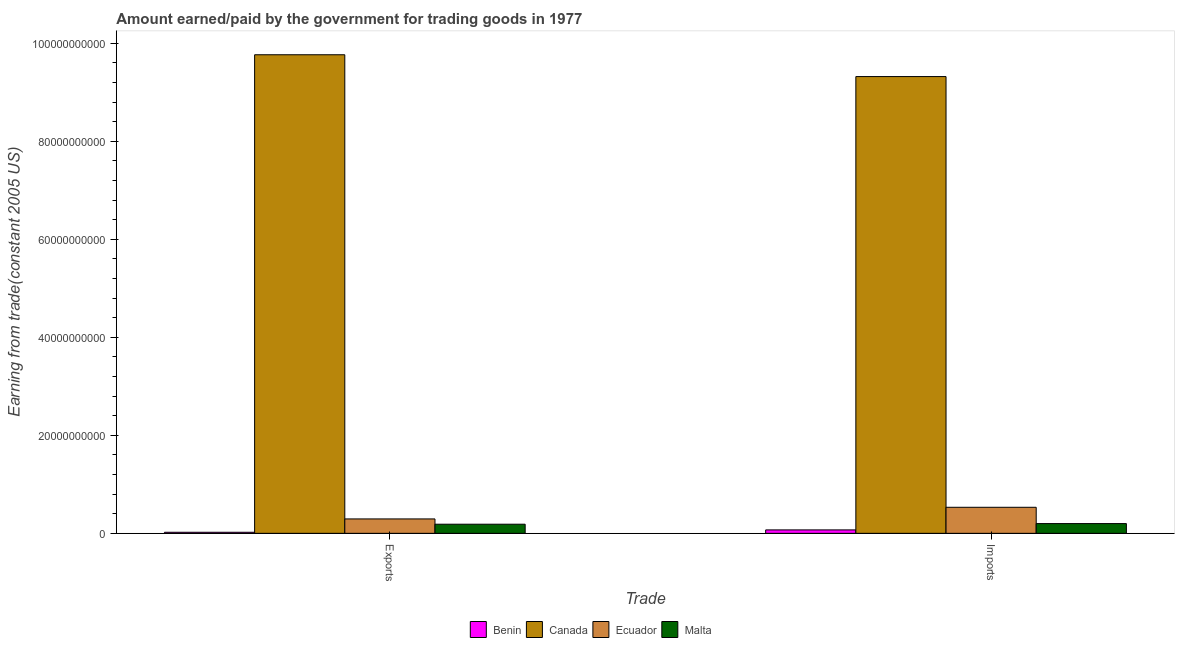How many groups of bars are there?
Your answer should be compact. 2. Are the number of bars per tick equal to the number of legend labels?
Offer a terse response. Yes. What is the label of the 1st group of bars from the left?
Your answer should be compact. Exports. What is the amount paid for imports in Malta?
Offer a terse response. 1.99e+09. Across all countries, what is the maximum amount paid for imports?
Provide a succinct answer. 9.32e+1. Across all countries, what is the minimum amount paid for imports?
Keep it short and to the point. 7.00e+08. In which country was the amount earned from exports minimum?
Provide a short and direct response. Benin. What is the total amount paid for imports in the graph?
Offer a very short reply. 1.01e+11. What is the difference between the amount paid for imports in Malta and that in Ecuador?
Make the answer very short. -3.33e+09. What is the difference between the amount earned from exports in Malta and the amount paid for imports in Benin?
Offer a terse response. 1.16e+09. What is the average amount earned from exports per country?
Your response must be concise. 2.57e+1. What is the difference between the amount paid for imports and amount earned from exports in Ecuador?
Make the answer very short. 2.38e+09. What is the ratio of the amount earned from exports in Ecuador to that in Canada?
Provide a short and direct response. 0.03. What does the 1st bar from the left in Exports represents?
Your answer should be compact. Benin. What does the 4th bar from the right in Exports represents?
Your answer should be compact. Benin. How many countries are there in the graph?
Your response must be concise. 4. What is the difference between two consecutive major ticks on the Y-axis?
Your answer should be very brief. 2.00e+1. Are the values on the major ticks of Y-axis written in scientific E-notation?
Keep it short and to the point. No. How many legend labels are there?
Your response must be concise. 4. What is the title of the graph?
Provide a succinct answer. Amount earned/paid by the government for trading goods in 1977. What is the label or title of the X-axis?
Give a very brief answer. Trade. What is the label or title of the Y-axis?
Provide a short and direct response. Earning from trade(constant 2005 US). What is the Earning from trade(constant 2005 US) in Benin in Exports?
Ensure brevity in your answer.  2.16e+08. What is the Earning from trade(constant 2005 US) in Canada in Exports?
Give a very brief answer. 9.77e+1. What is the Earning from trade(constant 2005 US) of Ecuador in Exports?
Keep it short and to the point. 2.94e+09. What is the Earning from trade(constant 2005 US) of Malta in Exports?
Ensure brevity in your answer.  1.86e+09. What is the Earning from trade(constant 2005 US) of Benin in Imports?
Offer a terse response. 7.00e+08. What is the Earning from trade(constant 2005 US) of Canada in Imports?
Your answer should be very brief. 9.32e+1. What is the Earning from trade(constant 2005 US) of Ecuador in Imports?
Make the answer very short. 5.32e+09. What is the Earning from trade(constant 2005 US) of Malta in Imports?
Your answer should be compact. 1.99e+09. Across all Trade, what is the maximum Earning from trade(constant 2005 US) in Benin?
Keep it short and to the point. 7.00e+08. Across all Trade, what is the maximum Earning from trade(constant 2005 US) in Canada?
Your answer should be very brief. 9.77e+1. Across all Trade, what is the maximum Earning from trade(constant 2005 US) in Ecuador?
Offer a terse response. 5.32e+09. Across all Trade, what is the maximum Earning from trade(constant 2005 US) in Malta?
Your answer should be compact. 1.99e+09. Across all Trade, what is the minimum Earning from trade(constant 2005 US) of Benin?
Make the answer very short. 2.16e+08. Across all Trade, what is the minimum Earning from trade(constant 2005 US) in Canada?
Give a very brief answer. 9.32e+1. Across all Trade, what is the minimum Earning from trade(constant 2005 US) in Ecuador?
Your response must be concise. 2.94e+09. Across all Trade, what is the minimum Earning from trade(constant 2005 US) in Malta?
Ensure brevity in your answer.  1.86e+09. What is the total Earning from trade(constant 2005 US) of Benin in the graph?
Offer a terse response. 9.15e+08. What is the total Earning from trade(constant 2005 US) in Canada in the graph?
Your answer should be compact. 1.91e+11. What is the total Earning from trade(constant 2005 US) of Ecuador in the graph?
Ensure brevity in your answer.  8.26e+09. What is the total Earning from trade(constant 2005 US) of Malta in the graph?
Your answer should be compact. 3.85e+09. What is the difference between the Earning from trade(constant 2005 US) of Benin in Exports and that in Imports?
Give a very brief answer. -4.84e+08. What is the difference between the Earning from trade(constant 2005 US) of Canada in Exports and that in Imports?
Give a very brief answer. 4.45e+09. What is the difference between the Earning from trade(constant 2005 US) in Ecuador in Exports and that in Imports?
Offer a terse response. -2.38e+09. What is the difference between the Earning from trade(constant 2005 US) of Malta in Exports and that in Imports?
Offer a very short reply. -1.30e+08. What is the difference between the Earning from trade(constant 2005 US) in Benin in Exports and the Earning from trade(constant 2005 US) in Canada in Imports?
Provide a succinct answer. -9.30e+1. What is the difference between the Earning from trade(constant 2005 US) of Benin in Exports and the Earning from trade(constant 2005 US) of Ecuador in Imports?
Provide a succinct answer. -5.10e+09. What is the difference between the Earning from trade(constant 2005 US) of Benin in Exports and the Earning from trade(constant 2005 US) of Malta in Imports?
Provide a short and direct response. -1.77e+09. What is the difference between the Earning from trade(constant 2005 US) in Canada in Exports and the Earning from trade(constant 2005 US) in Ecuador in Imports?
Give a very brief answer. 9.23e+1. What is the difference between the Earning from trade(constant 2005 US) in Canada in Exports and the Earning from trade(constant 2005 US) in Malta in Imports?
Your response must be concise. 9.57e+1. What is the difference between the Earning from trade(constant 2005 US) of Ecuador in Exports and the Earning from trade(constant 2005 US) of Malta in Imports?
Offer a terse response. 9.49e+08. What is the average Earning from trade(constant 2005 US) of Benin per Trade?
Offer a very short reply. 4.58e+08. What is the average Earning from trade(constant 2005 US) of Canada per Trade?
Ensure brevity in your answer.  9.54e+1. What is the average Earning from trade(constant 2005 US) in Ecuador per Trade?
Ensure brevity in your answer.  4.13e+09. What is the average Earning from trade(constant 2005 US) of Malta per Trade?
Ensure brevity in your answer.  1.93e+09. What is the difference between the Earning from trade(constant 2005 US) in Benin and Earning from trade(constant 2005 US) in Canada in Exports?
Provide a short and direct response. -9.74e+1. What is the difference between the Earning from trade(constant 2005 US) of Benin and Earning from trade(constant 2005 US) of Ecuador in Exports?
Your response must be concise. -2.72e+09. What is the difference between the Earning from trade(constant 2005 US) in Benin and Earning from trade(constant 2005 US) in Malta in Exports?
Provide a short and direct response. -1.64e+09. What is the difference between the Earning from trade(constant 2005 US) of Canada and Earning from trade(constant 2005 US) of Ecuador in Exports?
Provide a succinct answer. 9.47e+1. What is the difference between the Earning from trade(constant 2005 US) in Canada and Earning from trade(constant 2005 US) in Malta in Exports?
Your answer should be compact. 9.58e+1. What is the difference between the Earning from trade(constant 2005 US) in Ecuador and Earning from trade(constant 2005 US) in Malta in Exports?
Keep it short and to the point. 1.08e+09. What is the difference between the Earning from trade(constant 2005 US) in Benin and Earning from trade(constant 2005 US) in Canada in Imports?
Make the answer very short. -9.25e+1. What is the difference between the Earning from trade(constant 2005 US) of Benin and Earning from trade(constant 2005 US) of Ecuador in Imports?
Your response must be concise. -4.62e+09. What is the difference between the Earning from trade(constant 2005 US) in Benin and Earning from trade(constant 2005 US) in Malta in Imports?
Give a very brief answer. -1.29e+09. What is the difference between the Earning from trade(constant 2005 US) of Canada and Earning from trade(constant 2005 US) of Ecuador in Imports?
Your answer should be compact. 8.79e+1. What is the difference between the Earning from trade(constant 2005 US) of Canada and Earning from trade(constant 2005 US) of Malta in Imports?
Your answer should be very brief. 9.12e+1. What is the difference between the Earning from trade(constant 2005 US) in Ecuador and Earning from trade(constant 2005 US) in Malta in Imports?
Provide a short and direct response. 3.33e+09. What is the ratio of the Earning from trade(constant 2005 US) of Benin in Exports to that in Imports?
Your answer should be very brief. 0.31. What is the ratio of the Earning from trade(constant 2005 US) in Canada in Exports to that in Imports?
Give a very brief answer. 1.05. What is the ratio of the Earning from trade(constant 2005 US) of Ecuador in Exports to that in Imports?
Make the answer very short. 0.55. What is the ratio of the Earning from trade(constant 2005 US) of Malta in Exports to that in Imports?
Provide a short and direct response. 0.93. What is the difference between the highest and the second highest Earning from trade(constant 2005 US) in Benin?
Offer a terse response. 4.84e+08. What is the difference between the highest and the second highest Earning from trade(constant 2005 US) of Canada?
Your answer should be compact. 4.45e+09. What is the difference between the highest and the second highest Earning from trade(constant 2005 US) of Ecuador?
Your response must be concise. 2.38e+09. What is the difference between the highest and the second highest Earning from trade(constant 2005 US) in Malta?
Your answer should be very brief. 1.30e+08. What is the difference between the highest and the lowest Earning from trade(constant 2005 US) of Benin?
Offer a very short reply. 4.84e+08. What is the difference between the highest and the lowest Earning from trade(constant 2005 US) of Canada?
Provide a succinct answer. 4.45e+09. What is the difference between the highest and the lowest Earning from trade(constant 2005 US) in Ecuador?
Make the answer very short. 2.38e+09. What is the difference between the highest and the lowest Earning from trade(constant 2005 US) in Malta?
Ensure brevity in your answer.  1.30e+08. 